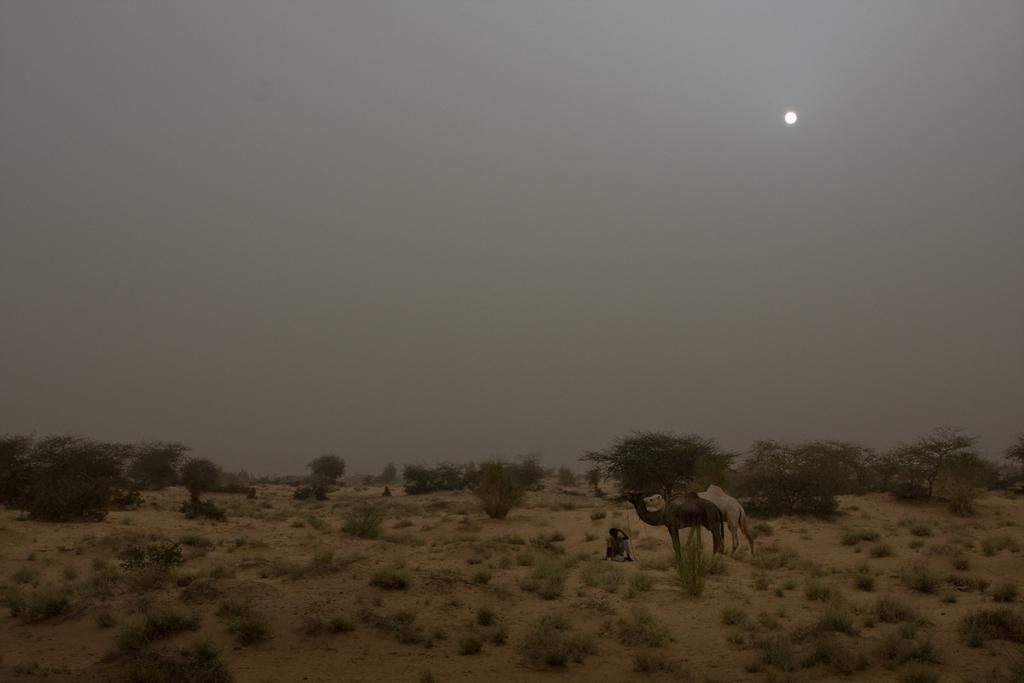What animals can be seen in the image? There are camels in the image. Who or what else is present in the image? There is a person in the image. What type of vegetation is visible in the image? There are trees and plants in the image. What celestial body is visible in the image? The moon is visible in the image. What part of the natural environment is visible in the image? The sky is visible in the image. What type of hook is being used to divide the stamp in the image? There is no hook, division, or stamp present in the image. 